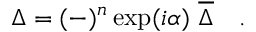Convert formula to latex. <formula><loc_0><loc_0><loc_500><loc_500>\Delta = ( - ) ^ { n } \exp ( i \alpha ) \ { \overline { \Delta } } \quad .</formula> 